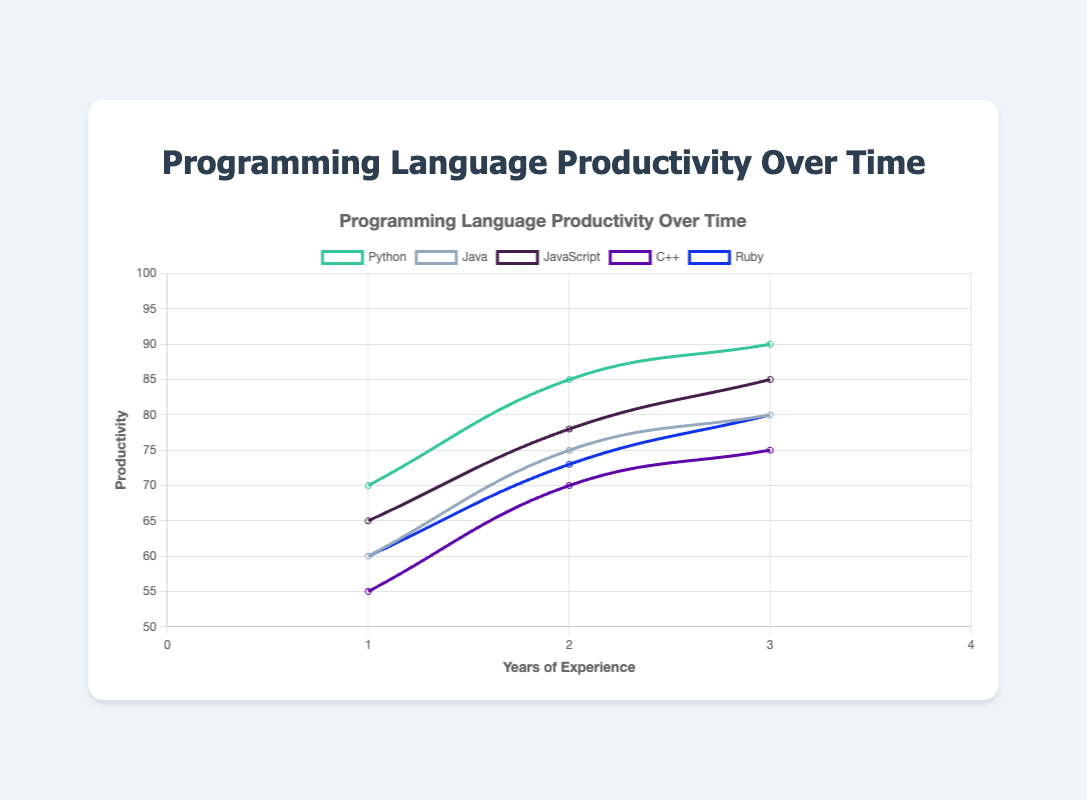Which programming language shows the highest productivity after 3 years of experience? By looking at the graph for productivity at the 3-year mark for each language, we see that Python has the highest productivity value at 90.
Answer: Python How does the productivity of Java compare to JavaScript after 1 year of experience? At the 1-year mark, Java's productivity is 60, whereas JavaScript's productivity is 65. JavaScript's productivity is higher.
Answer: JavaScript is higher What is the average productivity of Python over the 3-year period? Sum the productivity values of Python for each year: 70 + 85 + 90 = 245. Divide by the number of years: 245 / 3 = 81.67.
Answer: 81.67 Which two programming languages have the most similar productivity levels at 2 years of experience? At 2 years of experience, Java has a productivity of 75 and Ruby has a productivity of 73. These are the most similar values.
Answer: Java and Ruby Does C++ ever surpass Ruby in productivity over the 3-year period? Comparing the productivity values of C++ and Ruby for each year: Year 1 (C++: 55, Ruby: 60), Year 2 (C++: 70, Ruby: 73), Year 3 (C++: 75, Ruby: 80). Ruby's productivity is consistently higher than C++.
Answer: No What is the total increase in productivity for developers using JavaScript from 1 to 3 years of experience? The increase is calculated by subtracting the productivity value at year 1 from the productivity value at year 3 for JavaScript: 85 - 65 = 20.
Answer: 20 Which programming language demonstrates the least increase in productivity over the 3 years? Calculate the increase for each language from year 1 to year 3: Python (90-70=20), Java (80-60=20), JavaScript (85-65=20), C++ (75-55=20), Ruby (80-60=20). All languages have a 20-point increase.
Answer: All have equal increase What is the difference in productivity between Python and C++ in the first year of experience? Python's productivity in the first year is 70, and C++'s is 55. The difference is 70 - 55 = 15.
Answer: 15 Which language shows the highest slope of productivity gain from year 1 to year 2? Calculate the increase for each language from year 1 to year 2 and compare: Python (85-70=15), Java (75-60=15), JavaScript (78-65=13), C++ (70-55=15), Ruby (73-60=13). Python, Java, and C++ have the highest increase of 15.
Answer: Python, Java, and C++ 